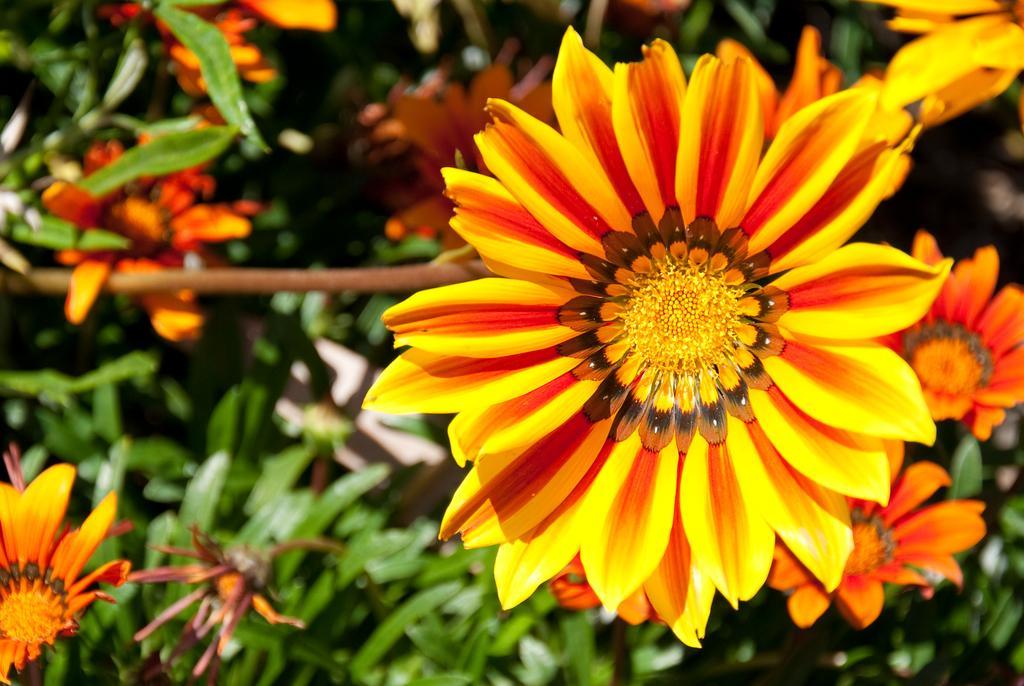In one or two sentences, can you explain what this image depicts? In this image we can see some plants with flowers. 